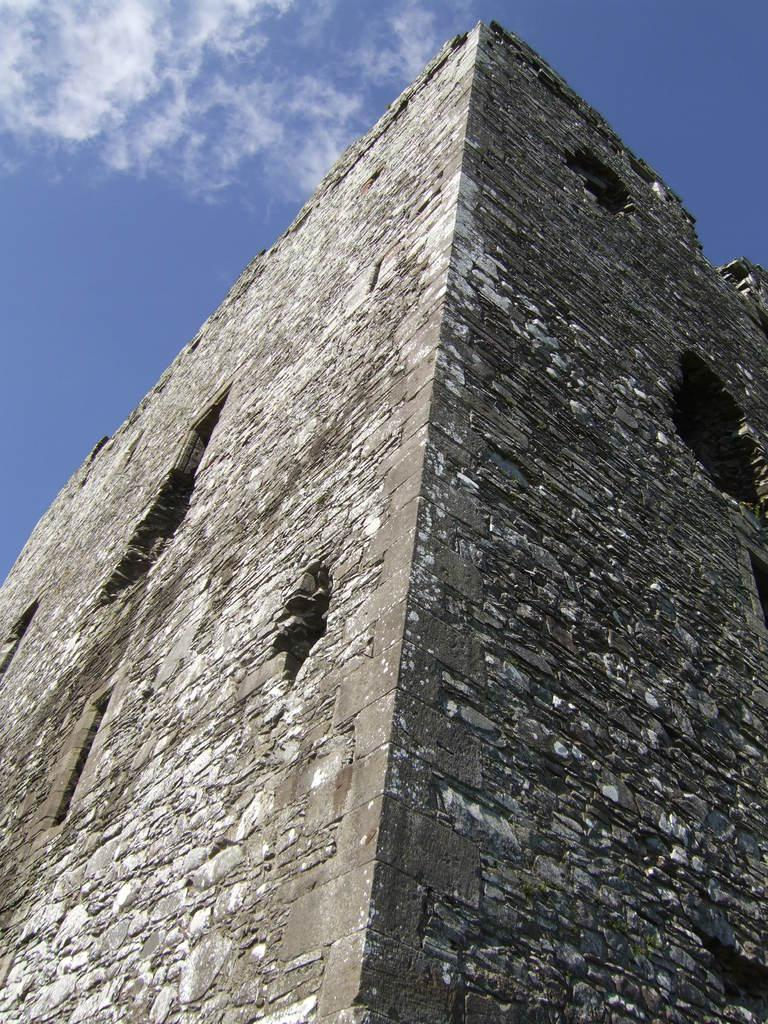What is the main structure in the image? There is a castle in the image. What colors are used to depict the castle? The castle is in grey and white color. What colors are present in the sky in the image? The sky is in white and blue color. What type of lace can be seen on the door of the castle in the image? There is no door or lace present in the image; it only features a castle and the sky. 